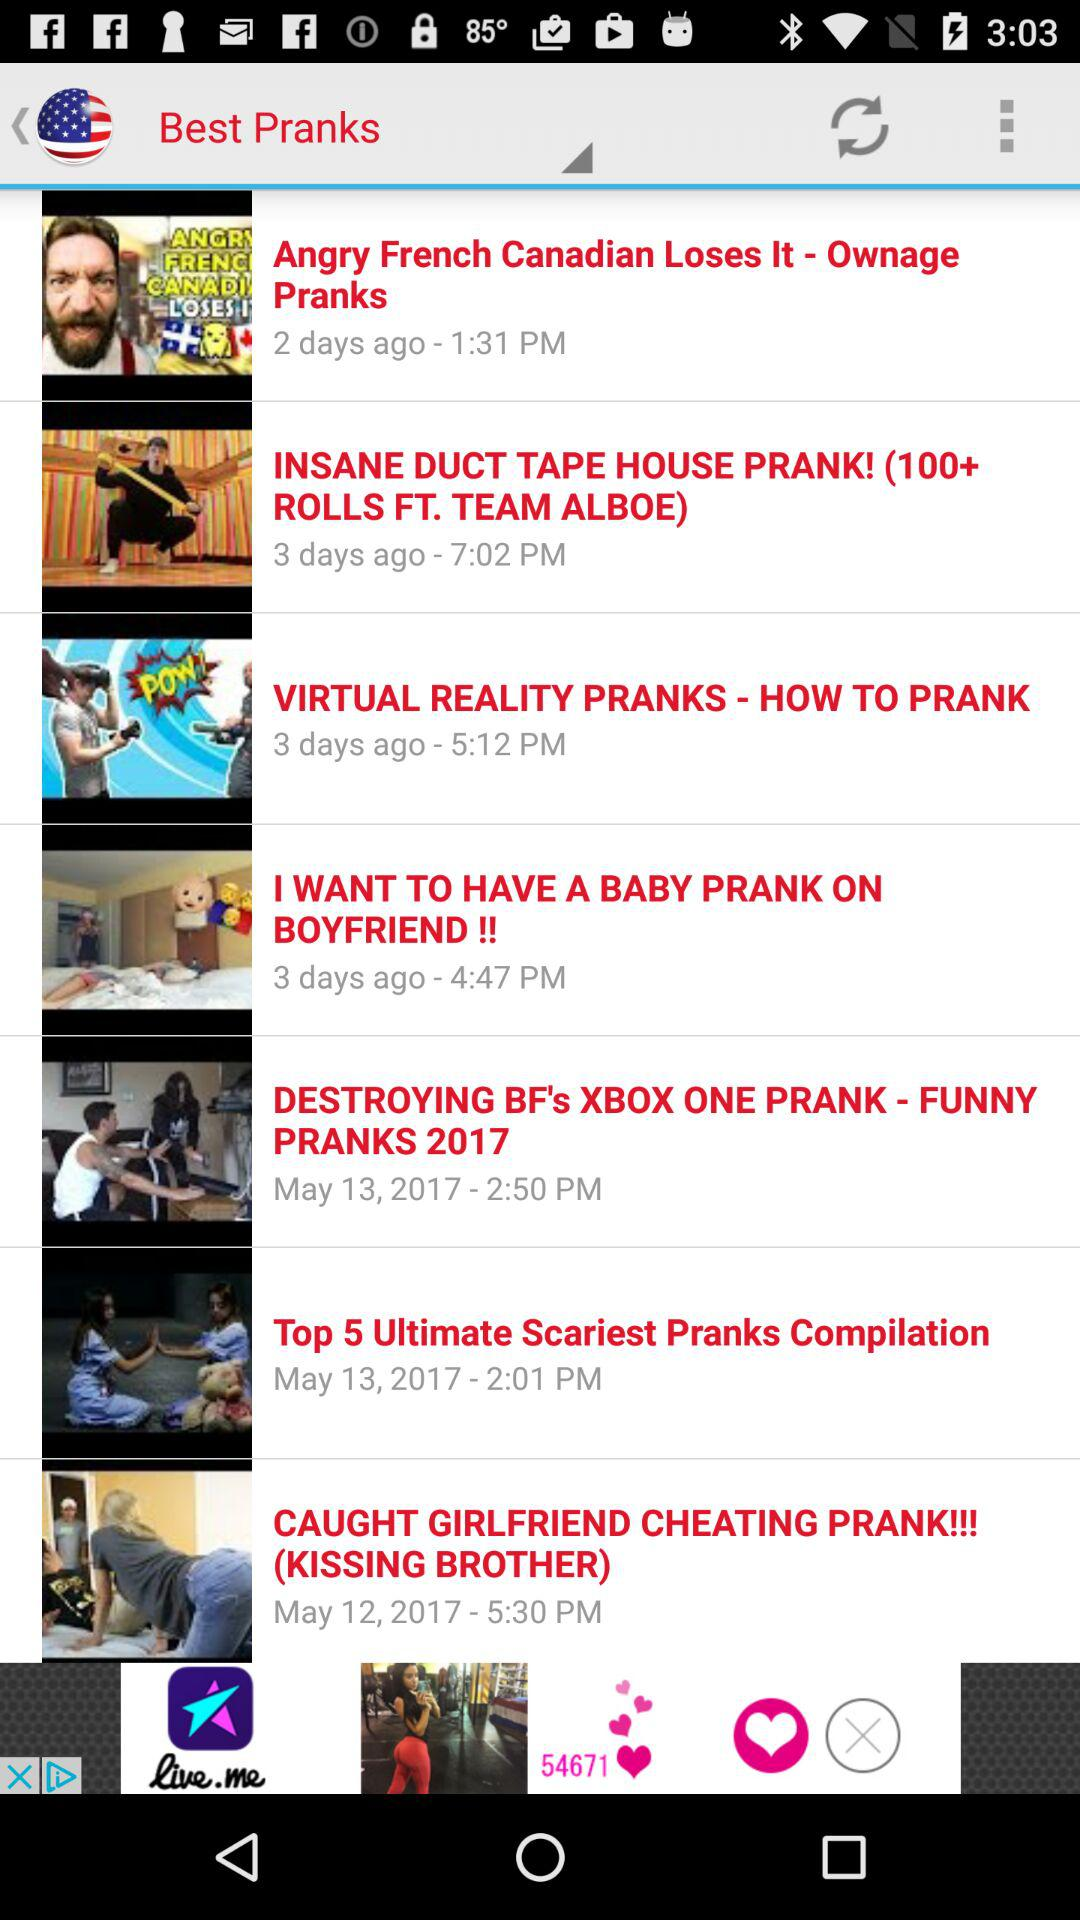At what time was the video "Top 5 Ultimate Scariest Pranks Compilation" posted? The video "Top 5 Ultimate Scariest Pranks Compilation" was posted at 2:01 p.m. 